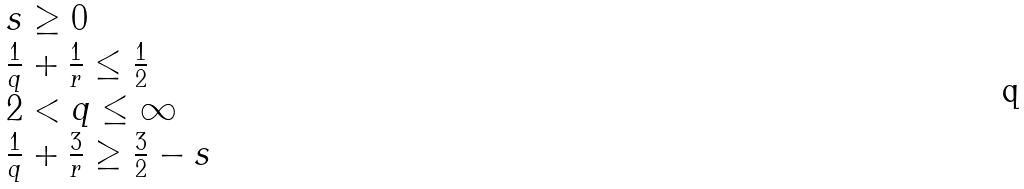Convert formula to latex. <formula><loc_0><loc_0><loc_500><loc_500>\begin{array} { l } s \geq 0 \\ \frac { 1 } { q } + \frac { 1 } { r } \leq \frac { 1 } { 2 } \\ 2 < q \leq \infty \\ \frac { 1 } { q } + \frac { 3 } { r } \geq \frac { 3 } { 2 } - s \end{array}</formula> 